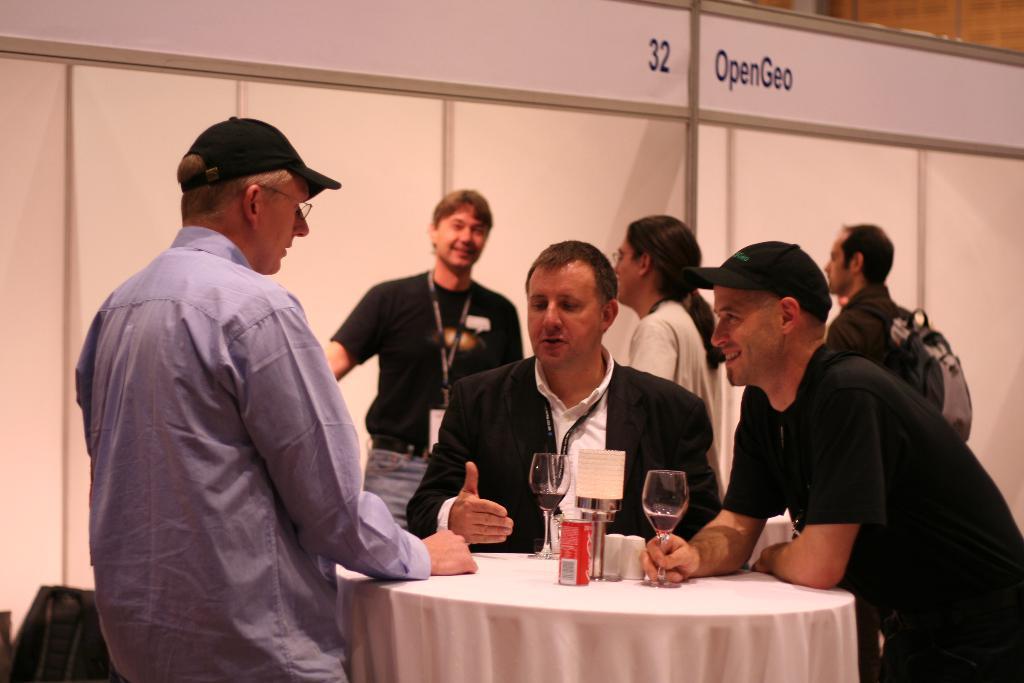How would you summarize this image in a sentence or two? In this image their are group of people who are discussing between them by standing around a round table. On the table there is a glass and cool drink. At the background their is a banner and a man who is wearing a bag. And the man to the left side is wearing a cap. 